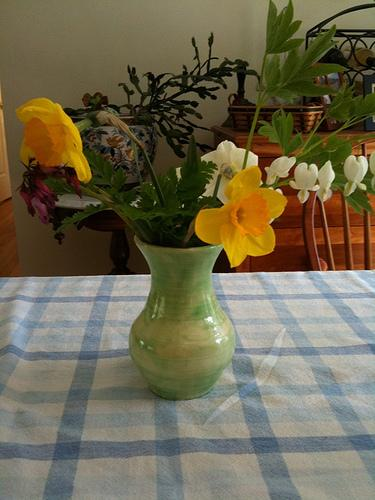Narrate a brief description of the image focusing on the main elements and their attributes. The image featured a bright yellow flower placed in a textured green vase, situated on a table adorned with a blue and white checkered tablecloth, with a wooden chair behind it. Write a short description of the image, highlighting the central figure and its setting. The image displays a yellow daffodil in a green and white vase as the central figure, positioned on a table with a blue and white plaid tablecloth, with wooden furniture in the background. Comment on the main focus of the image and its accompanying elements. A bright yellow flower in a green and white vase takes center stage, accompanied by a blue and white tablecloth, wooden chair, and various items in the background. Enumerate the key components visible in the image and their characteristics. Some prominent elements include: yellow daffodil in green vase, blue and white plaid tablecloth, wooden chair, wood dresser, white bleeding heart flowers, and a wine bottle in rack. Identify the primary object and its features in the image. A yellow flower in a green and white vase is prominently displayed, surrounded by other objects like a table with a blue and white plaid tablecloth and a wooden chair. Give a brief account of the main object and its surroundings in the image. The image shows a vibrant yellow flower in a green and white vase as the main object, surrounded by a table with a blue and white tablecloth, a wooden chair, and other decorative items. Mention the most striking object in the image and its accompanying details. A beautiful yellow flower in a green and white vase captures attention, surrounded by a blue and white plaid tablecloth, wooden chair, and other assorted items. Describe the image's primary subject and the environment it is placed in. The primary subject is a vivid yellow flower in a green and white vase, set on a table covered in a blue and white checkered tablecloth, amidst a room with wooden furniture. Provide a summary of the main focal point in the image and its context. The image's main focus is a striking yellow flower in a green and white vase, displayed on a table with a blue and white tablecloth and accompanied by various other items. Write a concise description of the central subject of the image. The central subject is a yellow daffodil in a green and white vase, sitting on a table with a blue and white tablecloth. 